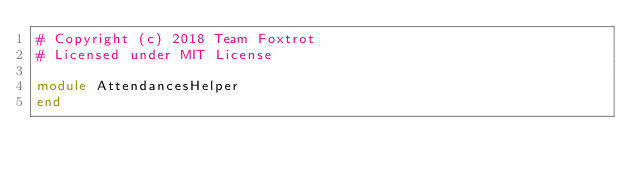Convert code to text. <code><loc_0><loc_0><loc_500><loc_500><_Ruby_># Copyright (c) 2018 Team Foxtrot
# Licensed under MIT License

module AttendancesHelper
end
</code> 